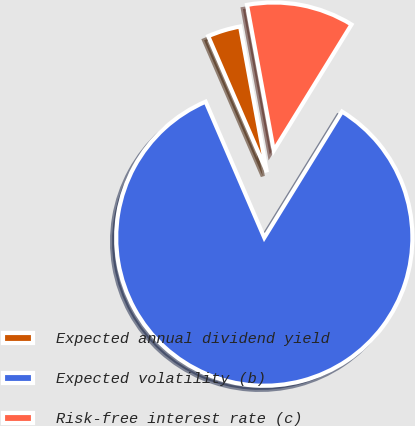Convert chart. <chart><loc_0><loc_0><loc_500><loc_500><pie_chart><fcel>Expected annual dividend yield<fcel>Expected volatility (b)<fcel>Risk-free interest rate (c)<nl><fcel>3.59%<fcel>84.72%<fcel>11.69%<nl></chart> 